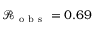<formula> <loc_0><loc_0><loc_500><loc_500>\mathcal { R _ { o b s } } = 0 . 6 9</formula> 